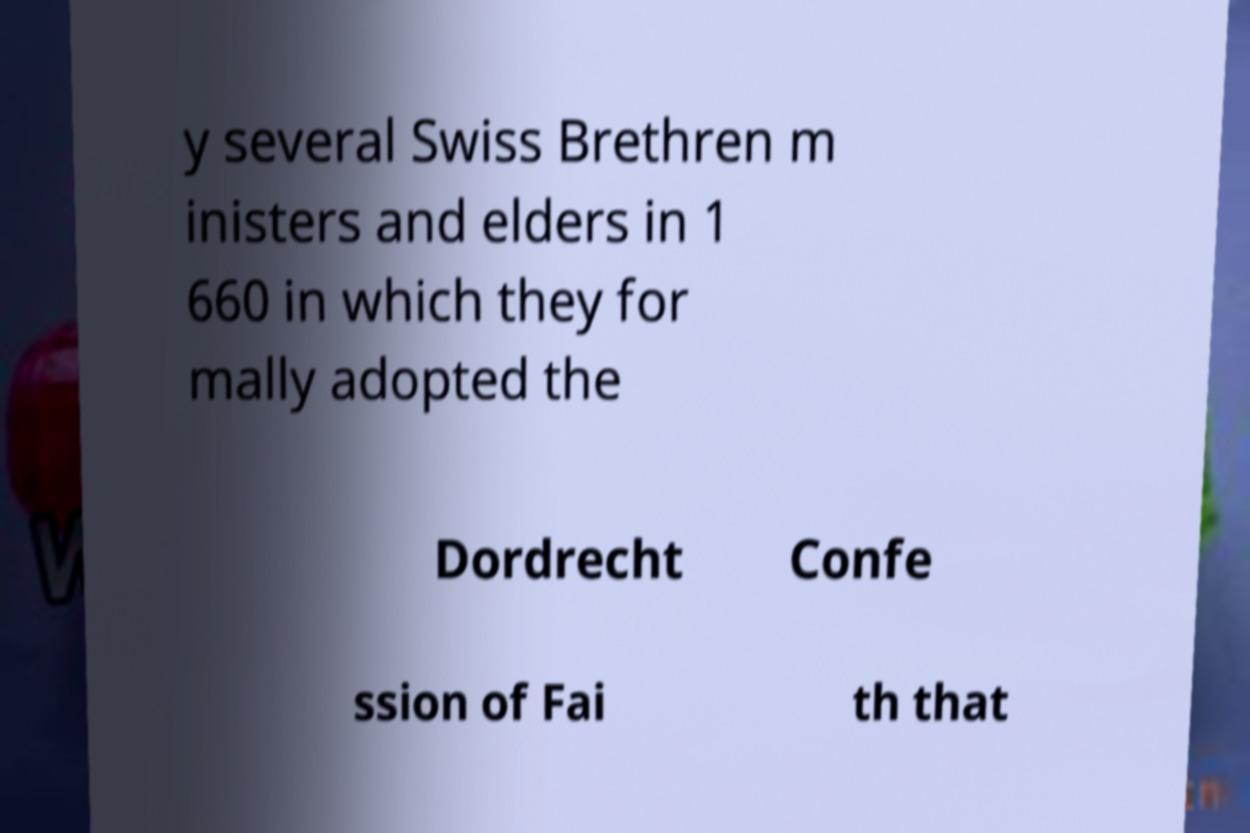Could you extract and type out the text from this image? y several Swiss Brethren m inisters and elders in 1 660 in which they for mally adopted the Dordrecht Confe ssion of Fai th that 